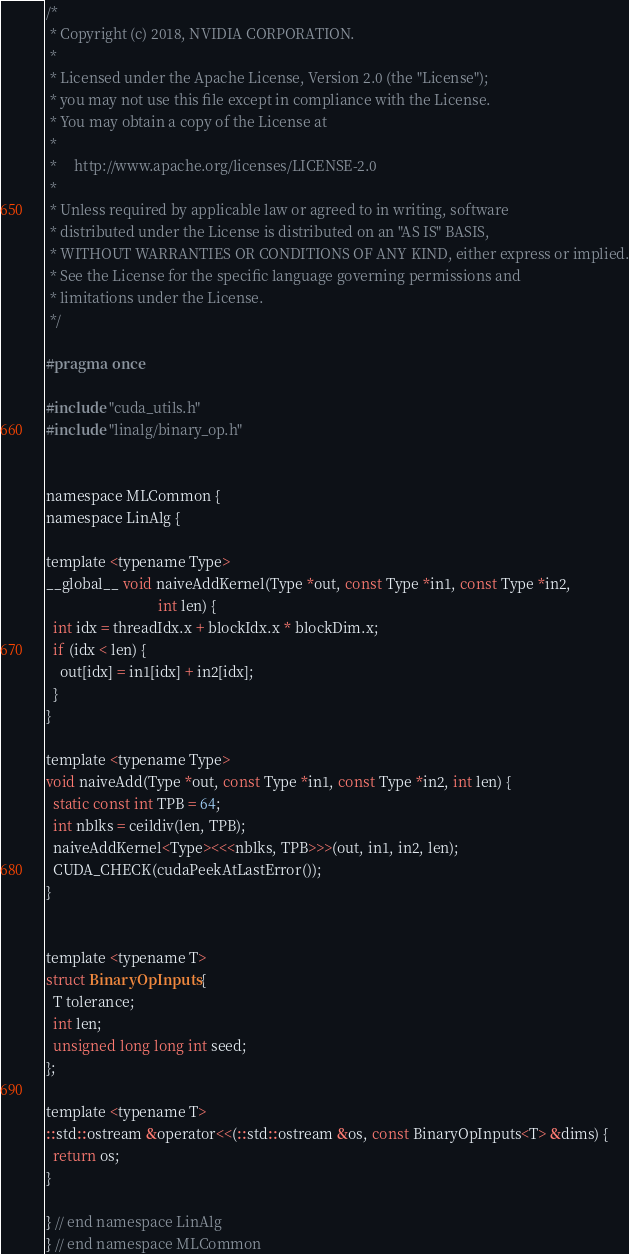<code> <loc_0><loc_0><loc_500><loc_500><_C_>/*
 * Copyright (c) 2018, NVIDIA CORPORATION.
 *
 * Licensed under the Apache License, Version 2.0 (the "License");
 * you may not use this file except in compliance with the License.
 * You may obtain a copy of the License at
 *
 *     http://www.apache.org/licenses/LICENSE-2.0
 *
 * Unless required by applicable law or agreed to in writing, software
 * distributed under the License is distributed on an "AS IS" BASIS,
 * WITHOUT WARRANTIES OR CONDITIONS OF ANY KIND, either express or implied.
 * See the License for the specific language governing permissions and
 * limitations under the License.
 */

#pragma once

#include "cuda_utils.h"
#include "linalg/binary_op.h"


namespace MLCommon {
namespace LinAlg {

template <typename Type>
__global__ void naiveAddKernel(Type *out, const Type *in1, const Type *in2,
                               int len) {
  int idx = threadIdx.x + blockIdx.x * blockDim.x;
  if (idx < len) {
    out[idx] = in1[idx] + in2[idx];
  }
}

template <typename Type>
void naiveAdd(Type *out, const Type *in1, const Type *in2, int len) {
  static const int TPB = 64;
  int nblks = ceildiv(len, TPB);
  naiveAddKernel<Type><<<nblks, TPB>>>(out, in1, in2, len);
  CUDA_CHECK(cudaPeekAtLastError());
}


template <typename T>
struct BinaryOpInputs {
  T tolerance;
  int len;
  unsigned long long int seed;
};

template <typename T>
::std::ostream &operator<<(::std::ostream &os, const BinaryOpInputs<T> &dims) {
  return os;
}

} // end namespace LinAlg
} // end namespace MLCommon
</code> 